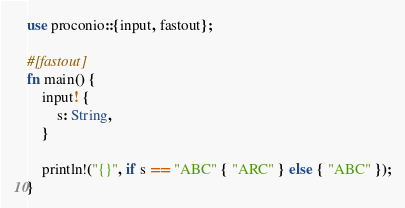<code> <loc_0><loc_0><loc_500><loc_500><_Rust_>use proconio::{input, fastout};

#[fastout]
fn main() {
    input! {
        s: String,
    }

    println!("{}", if s == "ABC" { "ARC" } else { "ABC" });
}
</code> 